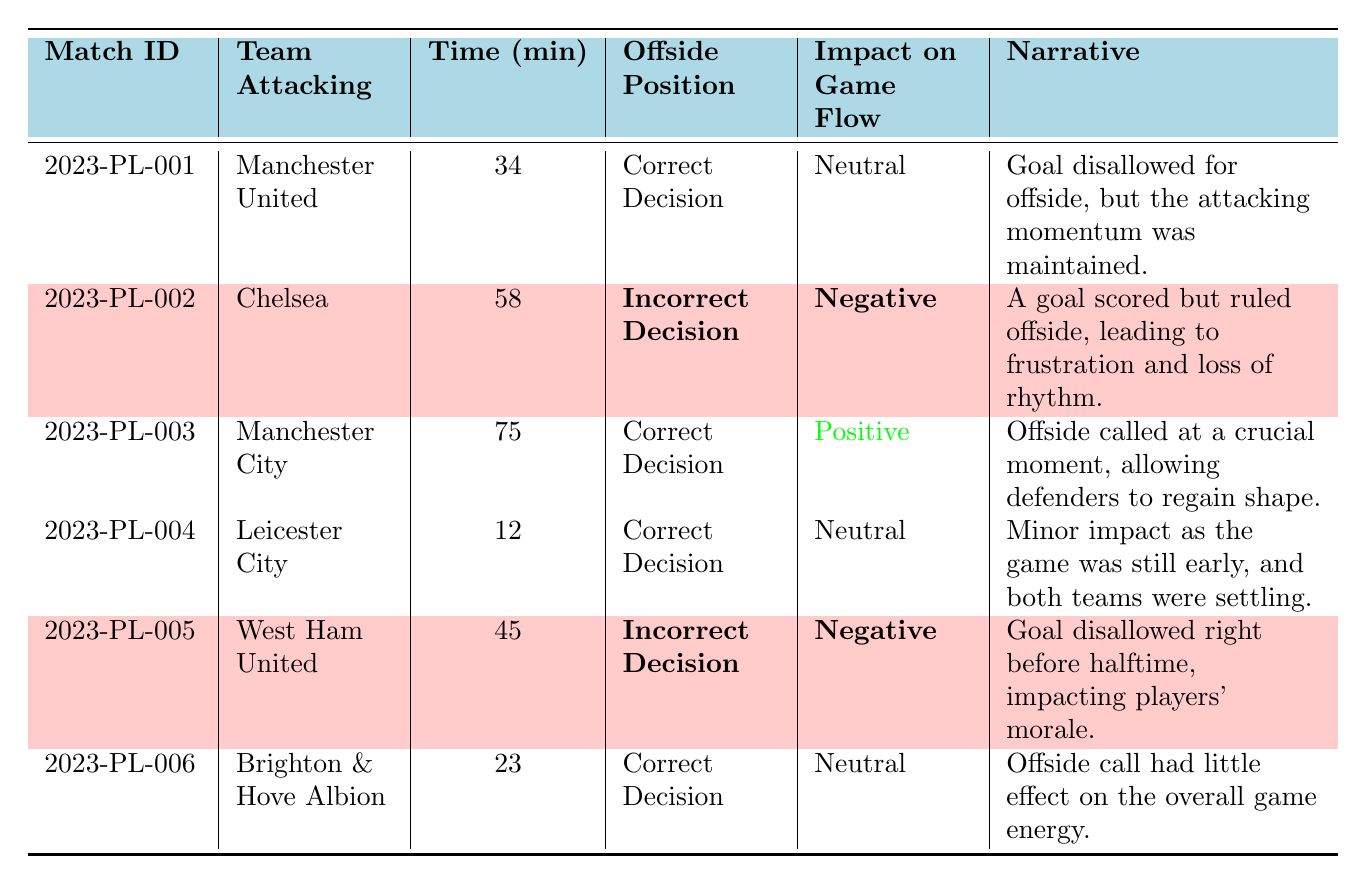What is the match ID for the offside decision that had a negative impact on game flow? The table lists two matches with a negative impact on game flow: Chelsea vs. Arsenal and West Ham United vs. Newcastle United, which correspond to match IDs 2023-PL-002 and 2023-PL-005.
Answer: 2023-PL-002, 2023-PL-005 How many correct offside decisions were made? The table shows that three matches had correct decisions: Manchester United vs. Liverpool, Manchester City vs. Tottenham Hotspur, and Leicester City vs. Everton.
Answer: 3 Which team was attacking during the offside decision at 58 minutes? According to the table, Chelsea was the attacking team during the offside decision at 58 minutes in match ID 2023-PL-002.
Answer: Chelsea What was the narrative associated with the incorrect decision for West Ham United? The table states that the narrative for the incorrect decision involving West Ham United was "Goal disallowed right before halftime, impacting players' morale."
Answer: Goal disallowed right before halftime, impacting players' morale Which of the matches had a neutral impact on game flow? Referring to the table, the matches that had a neutral impact on game flow are Manchester United vs. Liverpool, Leicester City vs. Everton, and Brighton & Hove Albion vs. Aston Villa.
Answer: Manchester United vs. Liverpool, Leicester City vs. Everton, Brighton & Hove Albion vs. Aston Villa What is the difference in minute timings for the incorrect decisions? The first incorrect decision is at minute 58 (Chelsea) and the second is at minute 45 (West Ham United). The difference is 58 - 45 = 13 minutes.
Answer: 13 minutes How many offside decisions were made before the 30th minute? The table indicates there were two matches with offside decisions before the 30th minute: the match involving Leicester City (12 minutes) and Brighton & Hove Albion (23 minutes).
Answer: 2 What percentage of the offside decisions were considered correct? There are 6 offside decisions in total, with 3 being correct. Therefore, the percentage is (3/6) x 100% = 50%.
Answer: 50% If a team is disallowed a goal due to an incorrect offside decision, what was the general impact noted? The narratives state that incorrectly ruled offsides led to frustration and loss of rhythm in the game, as seen with Chelsea and West Ham United.
Answer: Frustration and loss of rhythm 